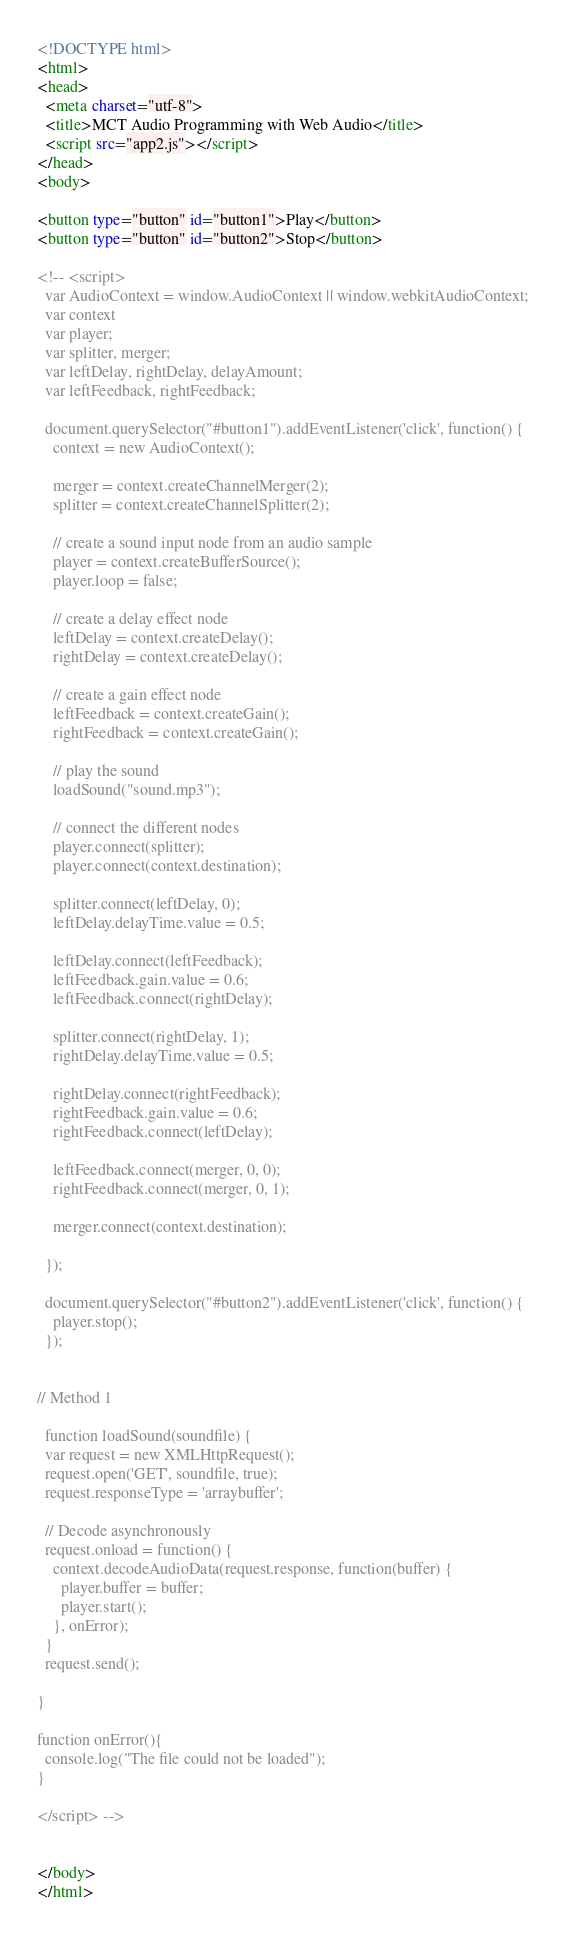<code> <loc_0><loc_0><loc_500><loc_500><_HTML_><!DOCTYPE html>
<html>
<head>
  <meta charset="utf-8">
  <title>MCT Audio Programming with Web Audio</title>
  <script src="app2.js"></script>
</head>
<body>

<button type="button" id="button1">Play</button>
<button type="button" id="button2">Stop</button>

<!-- <script>
  var AudioContext = window.AudioContext || window.webkitAudioContext;    
  var context
  var player; 
  var splitter, merger;    
  var leftDelay, rightDelay, delayAmount;
  var leftFeedback, rightFeedback;

  document.querySelector("#button1").addEventListener('click', function() {
    context = new AudioContext();

    merger = context.createChannelMerger(2);
    splitter = context.createChannelSplitter(2);

    // create a sound input node from an audio sample
    player = context.createBufferSource();
    player.loop = false;

    // create a delay effect node
    leftDelay = context.createDelay();
    rightDelay = context.createDelay();

    // create a gain effect node
    leftFeedback = context.createGain();
    rightFeedback = context.createGain();

    // play the sound
    loadSound("sound.mp3");

    // connect the different nodes
    player.connect(splitter);
    player.connect(context.destination);

    splitter.connect(leftDelay, 0);
    leftDelay.delayTime.value = 0.5;

    leftDelay.connect(leftFeedback);
    leftFeedback.gain.value = 0.6;
    leftFeedback.connect(rightDelay); 

    splitter.connect(rightDelay, 1);
    rightDelay.delayTime.value = 0.5;

    rightDelay.connect(rightFeedback);
    rightFeedback.gain.value = 0.6;    
    rightFeedback.connect(leftDelay);    

    leftFeedback.connect(merger, 0, 0);
    rightFeedback.connect(merger, 0, 1);

    merger.connect(context.destination); 

  });

  document.querySelector("#button2").addEventListener('click', function() {
    player.stop();
  });
 

// Method 1 

  function loadSound(soundfile) {
  var request = new XMLHttpRequest();
  request.open('GET', soundfile, true);
  request.responseType = 'arraybuffer';

  // Decode asynchronously
  request.onload = function() {
    context.decodeAudioData(request.response, function(buffer) {
      player.buffer = buffer;
      player.start();
    }, onError);
  }
  request.send();
  
}

function onError(){
  console.log("The file could not be loaded");
}
  
</script> -->


</body>
</html></code> 